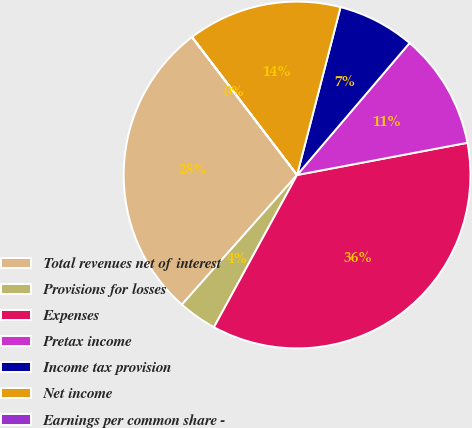Convert chart. <chart><loc_0><loc_0><loc_500><loc_500><pie_chart><fcel>Total revenues net of interest<fcel>Provisions for losses<fcel>Expenses<fcel>Pretax income<fcel>Income tax provision<fcel>Net income<fcel>Earnings per common share -<nl><fcel>28.06%<fcel>3.61%<fcel>35.92%<fcel>10.79%<fcel>7.2%<fcel>14.38%<fcel>0.02%<nl></chart> 